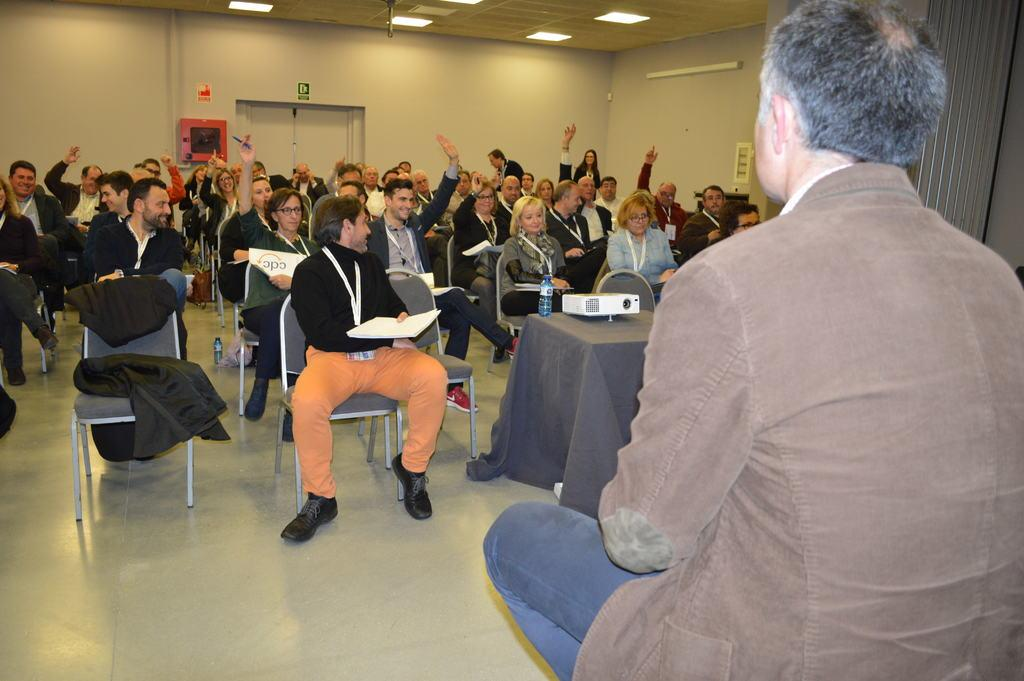How many people are in the image? There is a group of people in the image. What are the people in the image doing? The people are sitting in chairs. What is present in the image besides the people? There is a table, a projector, a bottle, a frame, a light, a door, and a person sitting in a chair. What is the texture of the temper in the image? There is no temper present in the image, and therefore no texture can be determined. 